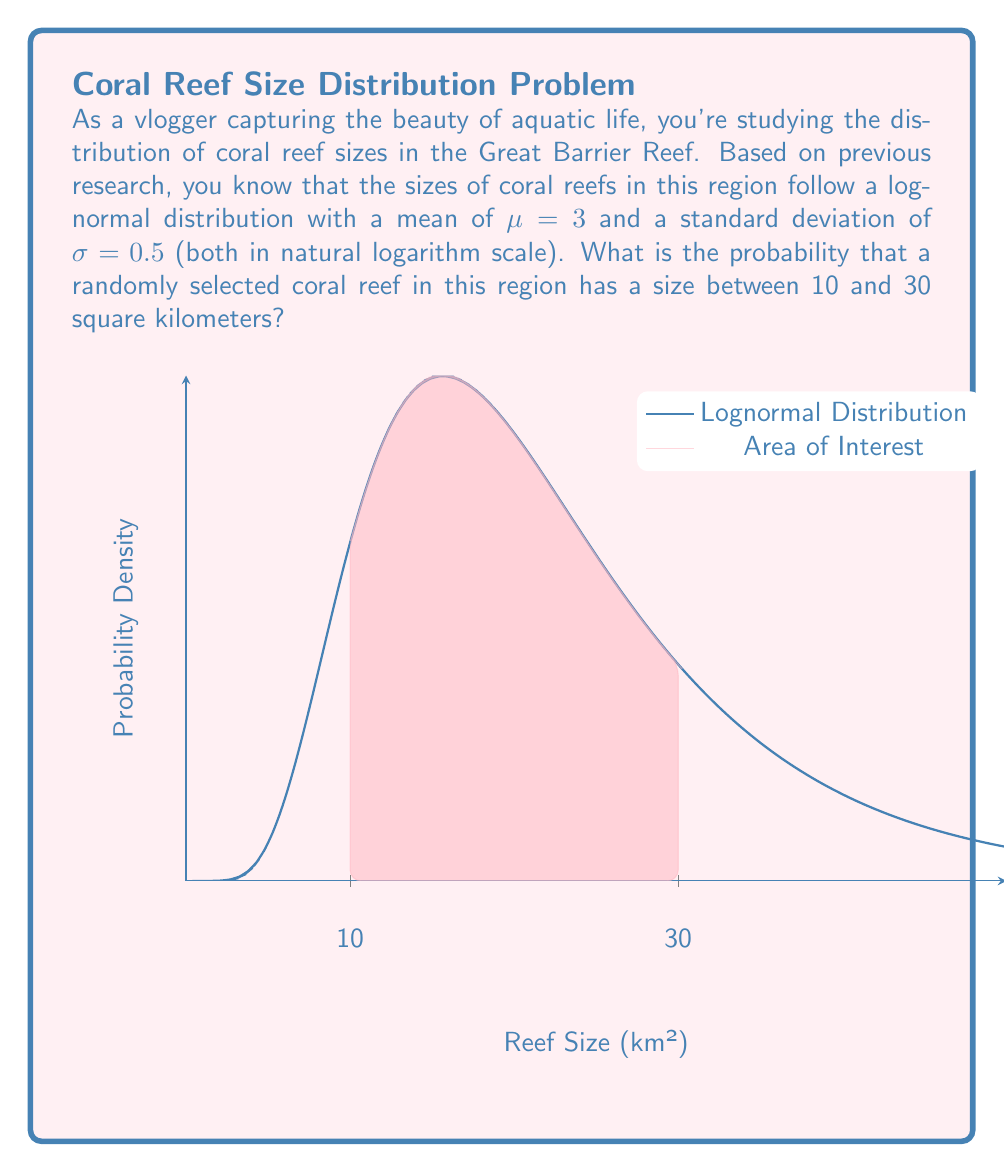Show me your answer to this math problem. To solve this problem, we'll follow these steps:

1) The lognormal distribution is given, with $\mu = 3$ and $\sigma = 0.5$ in the natural logarithm scale.

2) We need to find $P(10 < X < 30)$, where $X$ is the reef size in square kilometers.

3) For a lognormal distribution, we can use the standard normal distribution by transforming the variables:

   $P(10 < X < 30) = P(\frac{\ln(10) - \mu}{\sigma} < Z < \frac{\ln(30) - \mu}{\sigma})$

4) Calculate the lower bound:
   $\frac{\ln(10) - 3}{0.5} = \frac{2.30259 - 3}{0.5} = -1.39482$

5) Calculate the upper bound:
   $\frac{\ln(30) - 3}{0.5} = \frac{3.40120 - 3}{0.5} = 0.80240$

6) Now we need to find $P(-1.39482 < Z < 0.80240)$

7) Using the standard normal distribution table or a calculator:
   $P(Z < 0.80240) - P(Z < -1.39482)$
   $= 0.78881 - 0.08167$
   $= 0.70714$

Therefore, the probability that a randomly selected coral reef in this region has a size between 10 and 30 square kilometers is approximately 0.70714 or 70.714%.
Answer: 0.70714 